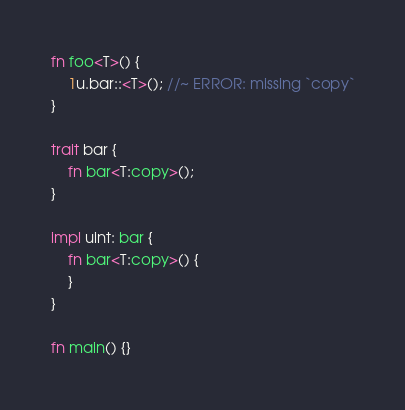Convert code to text. <code><loc_0><loc_0><loc_500><loc_500><_Rust_>fn foo<T>() {
    1u.bar::<T>(); //~ ERROR: missing `copy`
}

trait bar {
    fn bar<T:copy>();
}

impl uint: bar {
    fn bar<T:copy>() {
    }
}

fn main() {}
</code> 